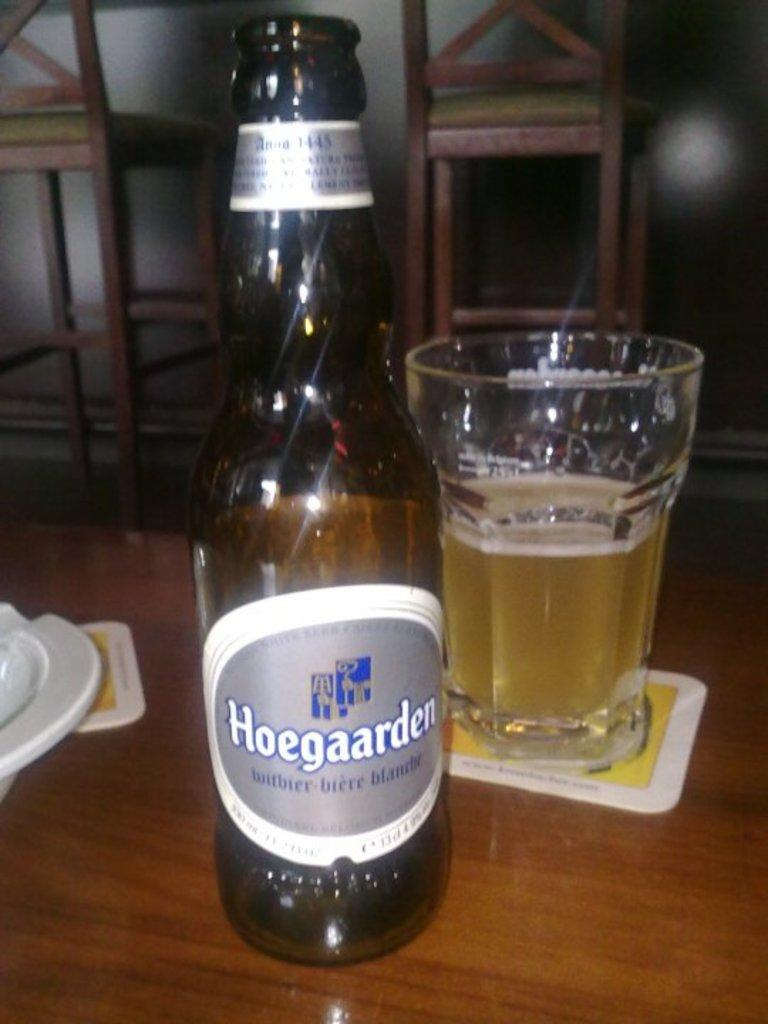<image>
Relay a brief, clear account of the picture shown. A bottle of Hoegaarden beer sits next to a half full glass. 